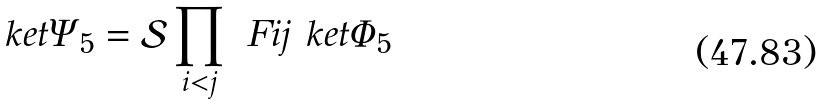<formula> <loc_0><loc_0><loc_500><loc_500>\ k e t { \Psi _ { 5 } } = \mathcal { S } \prod _ { i < j } \ F i j \ k e t { \Phi _ { 5 } }</formula> 